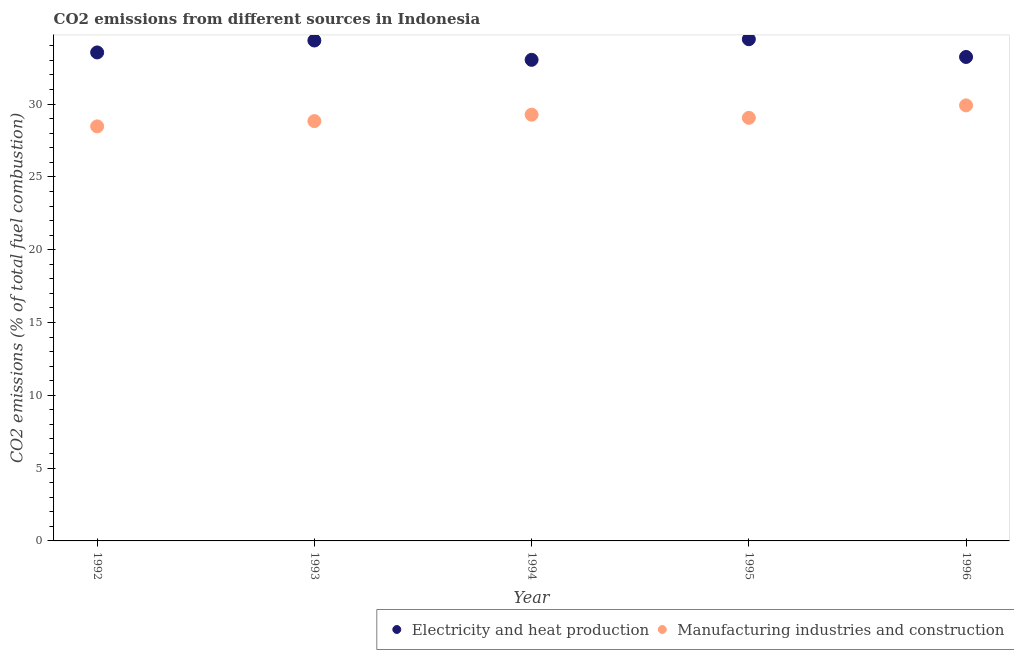What is the co2 emissions due to manufacturing industries in 1993?
Provide a short and direct response. 28.83. Across all years, what is the maximum co2 emissions due to electricity and heat production?
Your answer should be very brief. 34.45. Across all years, what is the minimum co2 emissions due to manufacturing industries?
Make the answer very short. 28.47. In which year was the co2 emissions due to electricity and heat production minimum?
Make the answer very short. 1994. What is the total co2 emissions due to electricity and heat production in the graph?
Your answer should be very brief. 168.64. What is the difference between the co2 emissions due to electricity and heat production in 1992 and that in 1996?
Keep it short and to the point. 0.31. What is the difference between the co2 emissions due to manufacturing industries in 1996 and the co2 emissions due to electricity and heat production in 1995?
Your response must be concise. -4.54. What is the average co2 emissions due to manufacturing industries per year?
Give a very brief answer. 29.11. In the year 1995, what is the difference between the co2 emissions due to manufacturing industries and co2 emissions due to electricity and heat production?
Ensure brevity in your answer.  -5.4. In how many years, is the co2 emissions due to manufacturing industries greater than 18 %?
Give a very brief answer. 5. What is the ratio of the co2 emissions due to manufacturing industries in 1992 to that in 1995?
Your response must be concise. 0.98. What is the difference between the highest and the second highest co2 emissions due to manufacturing industries?
Provide a short and direct response. 0.64. What is the difference between the highest and the lowest co2 emissions due to manufacturing industries?
Offer a very short reply. 1.44. In how many years, is the co2 emissions due to electricity and heat production greater than the average co2 emissions due to electricity and heat production taken over all years?
Make the answer very short. 2. How many dotlines are there?
Your answer should be very brief. 2. How many years are there in the graph?
Ensure brevity in your answer.  5. What is the difference between two consecutive major ticks on the Y-axis?
Provide a short and direct response. 5. How are the legend labels stacked?
Keep it short and to the point. Horizontal. What is the title of the graph?
Make the answer very short. CO2 emissions from different sources in Indonesia. Does "Goods and services" appear as one of the legend labels in the graph?
Keep it short and to the point. No. What is the label or title of the X-axis?
Provide a succinct answer. Year. What is the label or title of the Y-axis?
Give a very brief answer. CO2 emissions (% of total fuel combustion). What is the CO2 emissions (% of total fuel combustion) of Electricity and heat production in 1992?
Your answer should be compact. 33.55. What is the CO2 emissions (% of total fuel combustion) of Manufacturing industries and construction in 1992?
Make the answer very short. 28.47. What is the CO2 emissions (% of total fuel combustion) in Electricity and heat production in 1993?
Keep it short and to the point. 34.37. What is the CO2 emissions (% of total fuel combustion) in Manufacturing industries and construction in 1993?
Make the answer very short. 28.83. What is the CO2 emissions (% of total fuel combustion) in Electricity and heat production in 1994?
Ensure brevity in your answer.  33.04. What is the CO2 emissions (% of total fuel combustion) in Manufacturing industries and construction in 1994?
Your answer should be very brief. 29.27. What is the CO2 emissions (% of total fuel combustion) in Electricity and heat production in 1995?
Provide a short and direct response. 34.45. What is the CO2 emissions (% of total fuel combustion) in Manufacturing industries and construction in 1995?
Your answer should be compact. 29.06. What is the CO2 emissions (% of total fuel combustion) in Electricity and heat production in 1996?
Keep it short and to the point. 33.24. What is the CO2 emissions (% of total fuel combustion) in Manufacturing industries and construction in 1996?
Provide a short and direct response. 29.91. Across all years, what is the maximum CO2 emissions (% of total fuel combustion) of Electricity and heat production?
Your answer should be compact. 34.45. Across all years, what is the maximum CO2 emissions (% of total fuel combustion) in Manufacturing industries and construction?
Give a very brief answer. 29.91. Across all years, what is the minimum CO2 emissions (% of total fuel combustion) of Electricity and heat production?
Provide a succinct answer. 33.04. Across all years, what is the minimum CO2 emissions (% of total fuel combustion) of Manufacturing industries and construction?
Ensure brevity in your answer.  28.47. What is the total CO2 emissions (% of total fuel combustion) of Electricity and heat production in the graph?
Your answer should be compact. 168.64. What is the total CO2 emissions (% of total fuel combustion) of Manufacturing industries and construction in the graph?
Your answer should be compact. 145.54. What is the difference between the CO2 emissions (% of total fuel combustion) in Electricity and heat production in 1992 and that in 1993?
Make the answer very short. -0.82. What is the difference between the CO2 emissions (% of total fuel combustion) of Manufacturing industries and construction in 1992 and that in 1993?
Offer a very short reply. -0.36. What is the difference between the CO2 emissions (% of total fuel combustion) in Electricity and heat production in 1992 and that in 1994?
Your response must be concise. 0.51. What is the difference between the CO2 emissions (% of total fuel combustion) in Manufacturing industries and construction in 1992 and that in 1994?
Your response must be concise. -0.8. What is the difference between the CO2 emissions (% of total fuel combustion) in Electricity and heat production in 1992 and that in 1995?
Make the answer very short. -0.91. What is the difference between the CO2 emissions (% of total fuel combustion) of Manufacturing industries and construction in 1992 and that in 1995?
Your response must be concise. -0.59. What is the difference between the CO2 emissions (% of total fuel combustion) of Electricity and heat production in 1992 and that in 1996?
Make the answer very short. 0.31. What is the difference between the CO2 emissions (% of total fuel combustion) in Manufacturing industries and construction in 1992 and that in 1996?
Ensure brevity in your answer.  -1.44. What is the difference between the CO2 emissions (% of total fuel combustion) in Electricity and heat production in 1993 and that in 1994?
Your answer should be compact. 1.33. What is the difference between the CO2 emissions (% of total fuel combustion) of Manufacturing industries and construction in 1993 and that in 1994?
Give a very brief answer. -0.44. What is the difference between the CO2 emissions (% of total fuel combustion) in Electricity and heat production in 1993 and that in 1995?
Keep it short and to the point. -0.09. What is the difference between the CO2 emissions (% of total fuel combustion) of Manufacturing industries and construction in 1993 and that in 1995?
Ensure brevity in your answer.  -0.23. What is the difference between the CO2 emissions (% of total fuel combustion) of Electricity and heat production in 1993 and that in 1996?
Your answer should be very brief. 1.13. What is the difference between the CO2 emissions (% of total fuel combustion) in Manufacturing industries and construction in 1993 and that in 1996?
Keep it short and to the point. -1.08. What is the difference between the CO2 emissions (% of total fuel combustion) of Electricity and heat production in 1994 and that in 1995?
Provide a succinct answer. -1.41. What is the difference between the CO2 emissions (% of total fuel combustion) of Manufacturing industries and construction in 1994 and that in 1995?
Ensure brevity in your answer.  0.22. What is the difference between the CO2 emissions (% of total fuel combustion) of Electricity and heat production in 1994 and that in 1996?
Ensure brevity in your answer.  -0.2. What is the difference between the CO2 emissions (% of total fuel combustion) of Manufacturing industries and construction in 1994 and that in 1996?
Your answer should be compact. -0.64. What is the difference between the CO2 emissions (% of total fuel combustion) of Electricity and heat production in 1995 and that in 1996?
Your response must be concise. 1.22. What is the difference between the CO2 emissions (% of total fuel combustion) of Manufacturing industries and construction in 1995 and that in 1996?
Give a very brief answer. -0.85. What is the difference between the CO2 emissions (% of total fuel combustion) of Electricity and heat production in 1992 and the CO2 emissions (% of total fuel combustion) of Manufacturing industries and construction in 1993?
Your answer should be very brief. 4.71. What is the difference between the CO2 emissions (% of total fuel combustion) of Electricity and heat production in 1992 and the CO2 emissions (% of total fuel combustion) of Manufacturing industries and construction in 1994?
Your response must be concise. 4.27. What is the difference between the CO2 emissions (% of total fuel combustion) in Electricity and heat production in 1992 and the CO2 emissions (% of total fuel combustion) in Manufacturing industries and construction in 1995?
Provide a succinct answer. 4.49. What is the difference between the CO2 emissions (% of total fuel combustion) in Electricity and heat production in 1992 and the CO2 emissions (% of total fuel combustion) in Manufacturing industries and construction in 1996?
Provide a succinct answer. 3.64. What is the difference between the CO2 emissions (% of total fuel combustion) in Electricity and heat production in 1993 and the CO2 emissions (% of total fuel combustion) in Manufacturing industries and construction in 1994?
Provide a succinct answer. 5.09. What is the difference between the CO2 emissions (% of total fuel combustion) of Electricity and heat production in 1993 and the CO2 emissions (% of total fuel combustion) of Manufacturing industries and construction in 1995?
Ensure brevity in your answer.  5.31. What is the difference between the CO2 emissions (% of total fuel combustion) of Electricity and heat production in 1993 and the CO2 emissions (% of total fuel combustion) of Manufacturing industries and construction in 1996?
Make the answer very short. 4.45. What is the difference between the CO2 emissions (% of total fuel combustion) of Electricity and heat production in 1994 and the CO2 emissions (% of total fuel combustion) of Manufacturing industries and construction in 1995?
Keep it short and to the point. 3.98. What is the difference between the CO2 emissions (% of total fuel combustion) in Electricity and heat production in 1994 and the CO2 emissions (% of total fuel combustion) in Manufacturing industries and construction in 1996?
Ensure brevity in your answer.  3.13. What is the difference between the CO2 emissions (% of total fuel combustion) in Electricity and heat production in 1995 and the CO2 emissions (% of total fuel combustion) in Manufacturing industries and construction in 1996?
Provide a succinct answer. 4.54. What is the average CO2 emissions (% of total fuel combustion) in Electricity and heat production per year?
Your answer should be very brief. 33.73. What is the average CO2 emissions (% of total fuel combustion) in Manufacturing industries and construction per year?
Provide a short and direct response. 29.11. In the year 1992, what is the difference between the CO2 emissions (% of total fuel combustion) of Electricity and heat production and CO2 emissions (% of total fuel combustion) of Manufacturing industries and construction?
Your answer should be compact. 5.08. In the year 1993, what is the difference between the CO2 emissions (% of total fuel combustion) of Electricity and heat production and CO2 emissions (% of total fuel combustion) of Manufacturing industries and construction?
Provide a succinct answer. 5.53. In the year 1994, what is the difference between the CO2 emissions (% of total fuel combustion) in Electricity and heat production and CO2 emissions (% of total fuel combustion) in Manufacturing industries and construction?
Your response must be concise. 3.77. In the year 1995, what is the difference between the CO2 emissions (% of total fuel combustion) in Electricity and heat production and CO2 emissions (% of total fuel combustion) in Manufacturing industries and construction?
Your answer should be very brief. 5.4. In the year 1996, what is the difference between the CO2 emissions (% of total fuel combustion) of Electricity and heat production and CO2 emissions (% of total fuel combustion) of Manufacturing industries and construction?
Ensure brevity in your answer.  3.33. What is the ratio of the CO2 emissions (% of total fuel combustion) of Electricity and heat production in 1992 to that in 1993?
Your response must be concise. 0.98. What is the ratio of the CO2 emissions (% of total fuel combustion) of Manufacturing industries and construction in 1992 to that in 1993?
Offer a terse response. 0.99. What is the ratio of the CO2 emissions (% of total fuel combustion) of Electricity and heat production in 1992 to that in 1994?
Make the answer very short. 1.02. What is the ratio of the CO2 emissions (% of total fuel combustion) of Manufacturing industries and construction in 1992 to that in 1994?
Offer a very short reply. 0.97. What is the ratio of the CO2 emissions (% of total fuel combustion) in Electricity and heat production in 1992 to that in 1995?
Offer a terse response. 0.97. What is the ratio of the CO2 emissions (% of total fuel combustion) of Manufacturing industries and construction in 1992 to that in 1995?
Offer a very short reply. 0.98. What is the ratio of the CO2 emissions (% of total fuel combustion) in Electricity and heat production in 1992 to that in 1996?
Keep it short and to the point. 1.01. What is the ratio of the CO2 emissions (% of total fuel combustion) in Manufacturing industries and construction in 1992 to that in 1996?
Provide a short and direct response. 0.95. What is the ratio of the CO2 emissions (% of total fuel combustion) in Electricity and heat production in 1993 to that in 1994?
Your response must be concise. 1.04. What is the ratio of the CO2 emissions (% of total fuel combustion) of Manufacturing industries and construction in 1993 to that in 1994?
Your response must be concise. 0.98. What is the ratio of the CO2 emissions (% of total fuel combustion) in Electricity and heat production in 1993 to that in 1996?
Provide a short and direct response. 1.03. What is the ratio of the CO2 emissions (% of total fuel combustion) of Manufacturing industries and construction in 1993 to that in 1996?
Your answer should be compact. 0.96. What is the ratio of the CO2 emissions (% of total fuel combustion) in Electricity and heat production in 1994 to that in 1995?
Keep it short and to the point. 0.96. What is the ratio of the CO2 emissions (% of total fuel combustion) in Manufacturing industries and construction in 1994 to that in 1995?
Ensure brevity in your answer.  1.01. What is the ratio of the CO2 emissions (% of total fuel combustion) of Manufacturing industries and construction in 1994 to that in 1996?
Offer a terse response. 0.98. What is the ratio of the CO2 emissions (% of total fuel combustion) in Electricity and heat production in 1995 to that in 1996?
Keep it short and to the point. 1.04. What is the ratio of the CO2 emissions (% of total fuel combustion) in Manufacturing industries and construction in 1995 to that in 1996?
Your response must be concise. 0.97. What is the difference between the highest and the second highest CO2 emissions (% of total fuel combustion) in Electricity and heat production?
Keep it short and to the point. 0.09. What is the difference between the highest and the second highest CO2 emissions (% of total fuel combustion) of Manufacturing industries and construction?
Your response must be concise. 0.64. What is the difference between the highest and the lowest CO2 emissions (% of total fuel combustion) of Electricity and heat production?
Your answer should be very brief. 1.41. What is the difference between the highest and the lowest CO2 emissions (% of total fuel combustion) in Manufacturing industries and construction?
Provide a succinct answer. 1.44. 